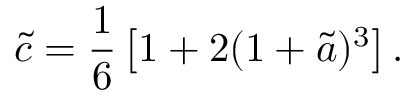Convert formula to latex. <formula><loc_0><loc_0><loc_500><loc_500>\tilde { c } = \frac { 1 } { 6 } \left [ 1 + 2 ( 1 + \tilde { a } ) ^ { 3 } \right ] .</formula> 